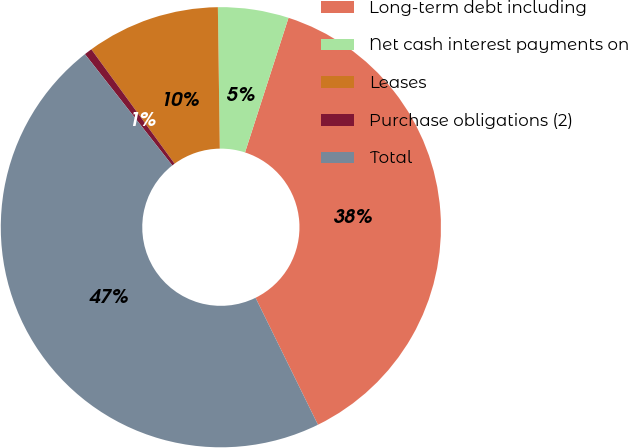<chart> <loc_0><loc_0><loc_500><loc_500><pie_chart><fcel>Long-term debt including<fcel>Net cash interest payments on<fcel>Leases<fcel>Purchase obligations (2)<fcel>Total<nl><fcel>37.76%<fcel>5.19%<fcel>9.8%<fcel>0.58%<fcel>46.68%<nl></chart> 